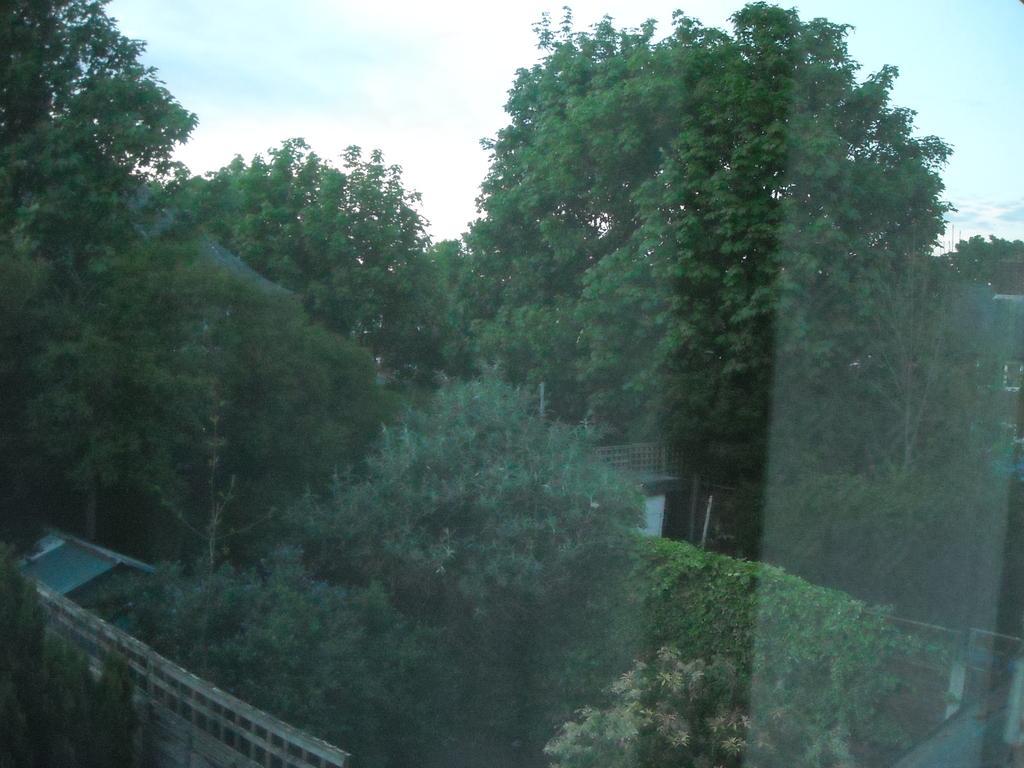In one or two sentences, can you explain what this image depicts? This picture is taken from the outside of the glass window. In this image, we can see some trees, plants, house and a wall. At the top, we can see a sky which is a bit cloudy. 